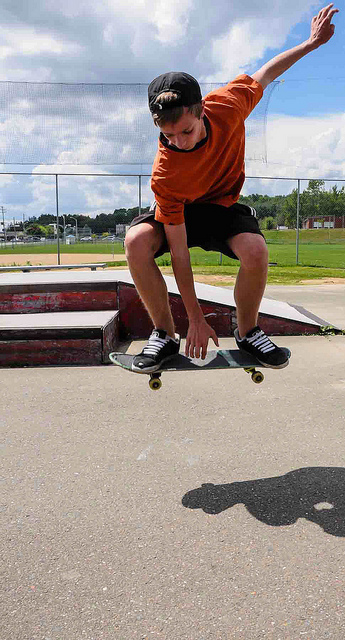How many motorcycles are between the sidewalk and the yellow line in the road? 0 